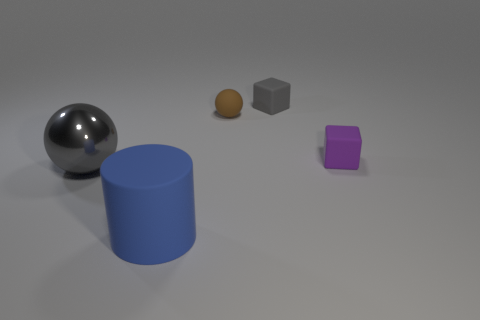Add 1 big purple spheres. How many objects exist? 6 Subtract all spheres. How many objects are left? 3 Add 5 small blue shiny objects. How many small blue shiny objects exist? 5 Subtract 1 gray spheres. How many objects are left? 4 Subtract all small brown rubber things. Subtract all gray spheres. How many objects are left? 3 Add 2 big blue rubber things. How many big blue rubber things are left? 3 